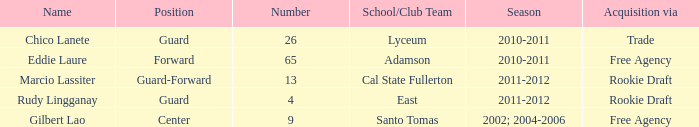What number has an acquisition via the Rookie Draft, and is part of a School/club team at Cal State Fullerton? 13.0. 